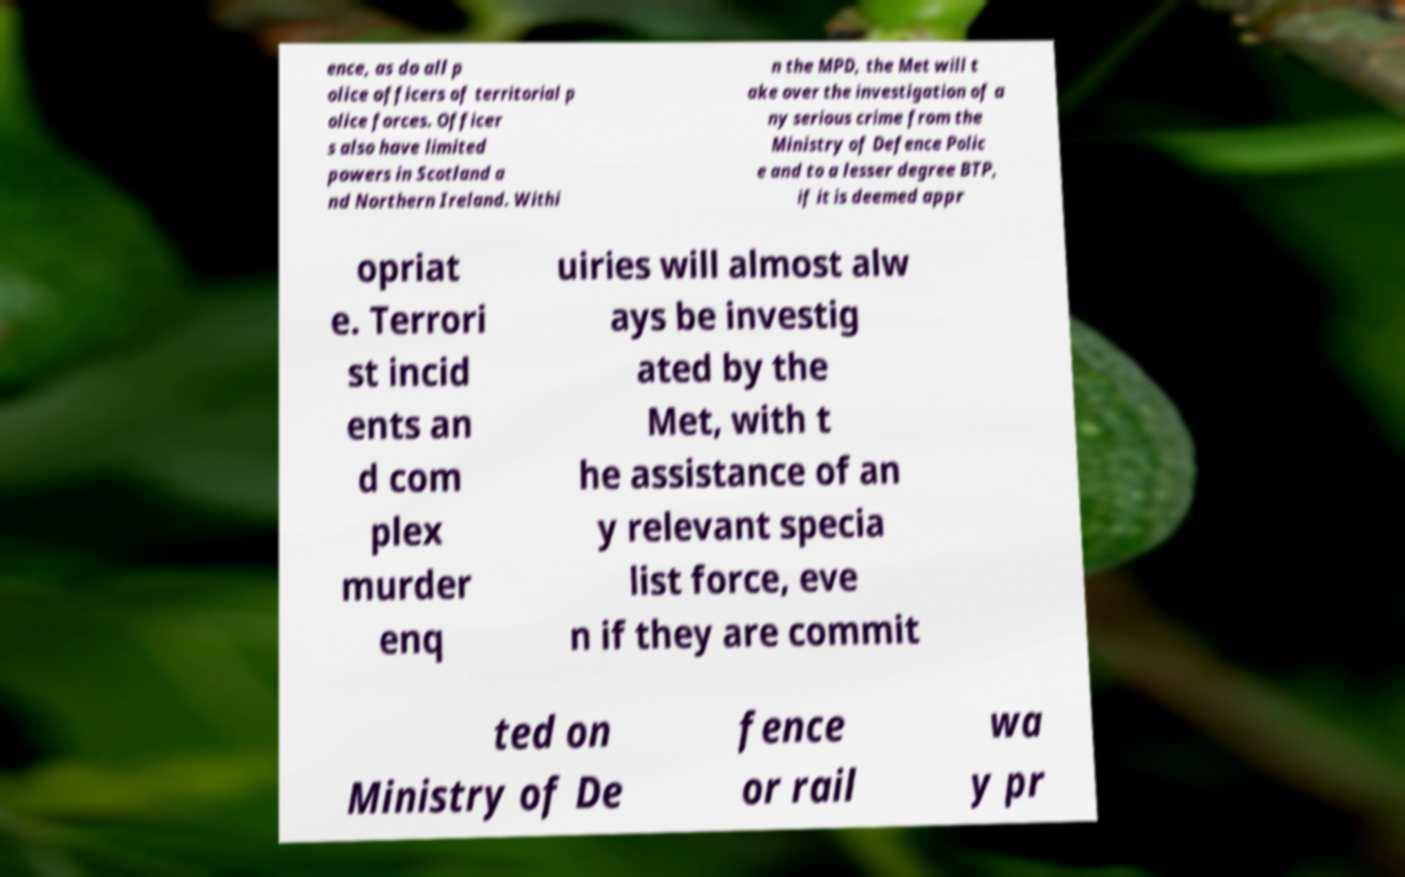Could you assist in decoding the text presented in this image and type it out clearly? ence, as do all p olice officers of territorial p olice forces. Officer s also have limited powers in Scotland a nd Northern Ireland. Withi n the MPD, the Met will t ake over the investigation of a ny serious crime from the Ministry of Defence Polic e and to a lesser degree BTP, if it is deemed appr opriat e. Terrori st incid ents an d com plex murder enq uiries will almost alw ays be investig ated by the Met, with t he assistance of an y relevant specia list force, eve n if they are commit ted on Ministry of De fence or rail wa y pr 